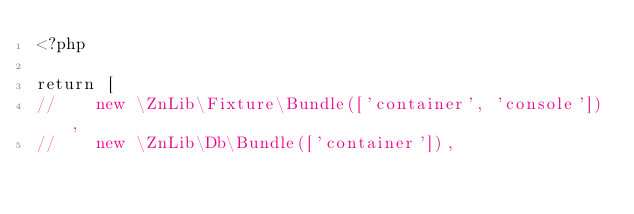<code> <loc_0><loc_0><loc_500><loc_500><_PHP_><?php

return [
//    new \ZnLib\Fixture\Bundle(['container', 'console']),
//    new \ZnLib\Db\Bundle(['container']),</code> 